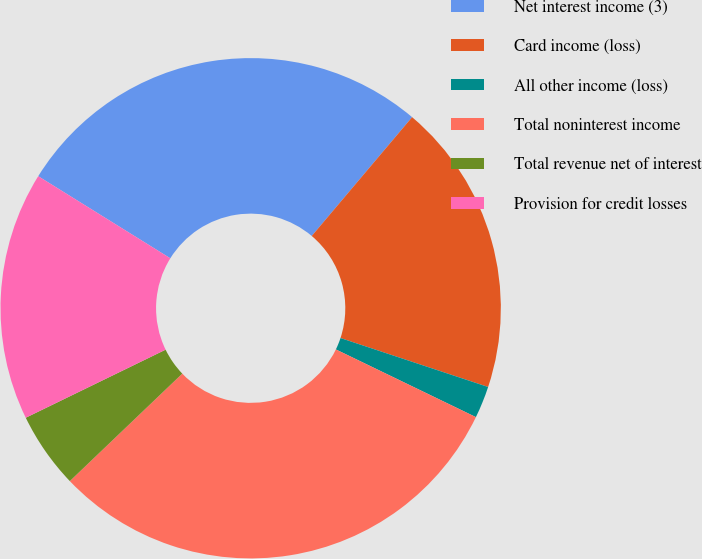<chart> <loc_0><loc_0><loc_500><loc_500><pie_chart><fcel>Net interest income (3)<fcel>Card income (loss)<fcel>All other income (loss)<fcel>Total noninterest income<fcel>Total revenue net of interest<fcel>Provision for credit losses<nl><fcel>27.31%<fcel>18.93%<fcel>2.07%<fcel>30.69%<fcel>4.93%<fcel>16.06%<nl></chart> 